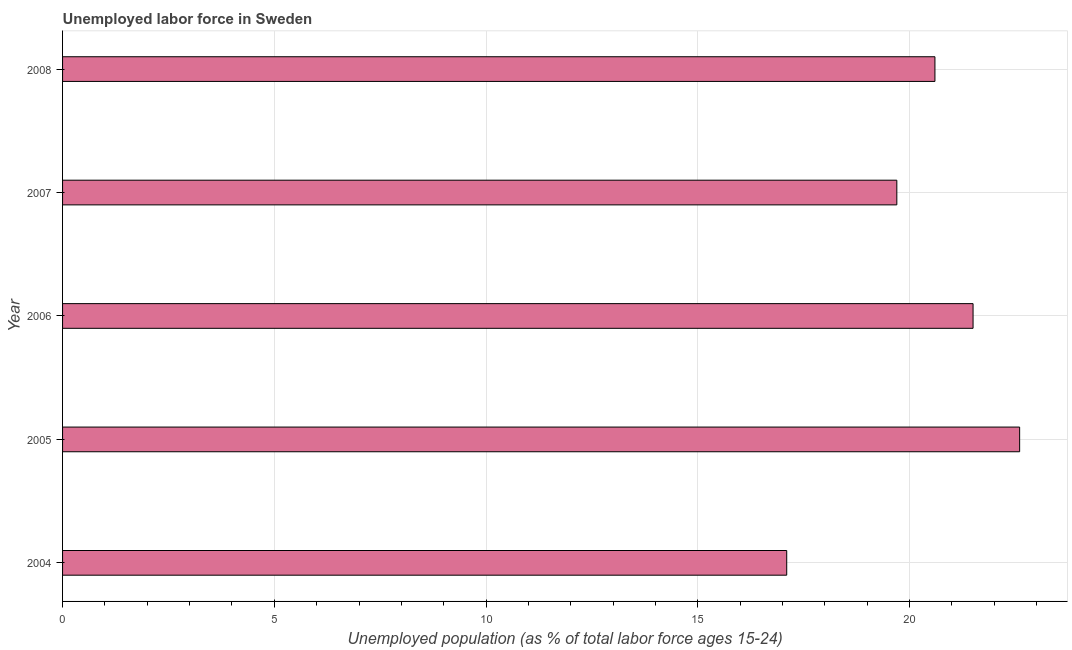Does the graph contain any zero values?
Give a very brief answer. No. Does the graph contain grids?
Offer a very short reply. Yes. What is the title of the graph?
Offer a very short reply. Unemployed labor force in Sweden. What is the label or title of the X-axis?
Give a very brief answer. Unemployed population (as % of total labor force ages 15-24). What is the total unemployed youth population in 2004?
Make the answer very short. 17.1. Across all years, what is the maximum total unemployed youth population?
Give a very brief answer. 22.6. Across all years, what is the minimum total unemployed youth population?
Offer a terse response. 17.1. What is the sum of the total unemployed youth population?
Provide a succinct answer. 101.5. What is the average total unemployed youth population per year?
Offer a terse response. 20.3. What is the median total unemployed youth population?
Keep it short and to the point. 20.6. What is the ratio of the total unemployed youth population in 2005 to that in 2008?
Keep it short and to the point. 1.1. Is the difference between the total unemployed youth population in 2004 and 2007 greater than the difference between any two years?
Your answer should be compact. No. In how many years, is the total unemployed youth population greater than the average total unemployed youth population taken over all years?
Make the answer very short. 3. Are all the bars in the graph horizontal?
Your answer should be compact. Yes. Are the values on the major ticks of X-axis written in scientific E-notation?
Offer a terse response. No. What is the Unemployed population (as % of total labor force ages 15-24) in 2004?
Offer a very short reply. 17.1. What is the Unemployed population (as % of total labor force ages 15-24) in 2005?
Your answer should be very brief. 22.6. What is the Unemployed population (as % of total labor force ages 15-24) in 2007?
Keep it short and to the point. 19.7. What is the Unemployed population (as % of total labor force ages 15-24) of 2008?
Give a very brief answer. 20.6. What is the difference between the Unemployed population (as % of total labor force ages 15-24) in 2005 and 2007?
Ensure brevity in your answer.  2.9. What is the difference between the Unemployed population (as % of total labor force ages 15-24) in 2005 and 2008?
Provide a short and direct response. 2. What is the difference between the Unemployed population (as % of total labor force ages 15-24) in 2006 and 2007?
Offer a terse response. 1.8. What is the difference between the Unemployed population (as % of total labor force ages 15-24) in 2006 and 2008?
Your answer should be very brief. 0.9. What is the difference between the Unemployed population (as % of total labor force ages 15-24) in 2007 and 2008?
Give a very brief answer. -0.9. What is the ratio of the Unemployed population (as % of total labor force ages 15-24) in 2004 to that in 2005?
Make the answer very short. 0.76. What is the ratio of the Unemployed population (as % of total labor force ages 15-24) in 2004 to that in 2006?
Your answer should be very brief. 0.8. What is the ratio of the Unemployed population (as % of total labor force ages 15-24) in 2004 to that in 2007?
Your answer should be very brief. 0.87. What is the ratio of the Unemployed population (as % of total labor force ages 15-24) in 2004 to that in 2008?
Keep it short and to the point. 0.83. What is the ratio of the Unemployed population (as % of total labor force ages 15-24) in 2005 to that in 2006?
Provide a short and direct response. 1.05. What is the ratio of the Unemployed population (as % of total labor force ages 15-24) in 2005 to that in 2007?
Your answer should be compact. 1.15. What is the ratio of the Unemployed population (as % of total labor force ages 15-24) in 2005 to that in 2008?
Your answer should be compact. 1.1. What is the ratio of the Unemployed population (as % of total labor force ages 15-24) in 2006 to that in 2007?
Ensure brevity in your answer.  1.09. What is the ratio of the Unemployed population (as % of total labor force ages 15-24) in 2006 to that in 2008?
Your response must be concise. 1.04. What is the ratio of the Unemployed population (as % of total labor force ages 15-24) in 2007 to that in 2008?
Provide a short and direct response. 0.96. 